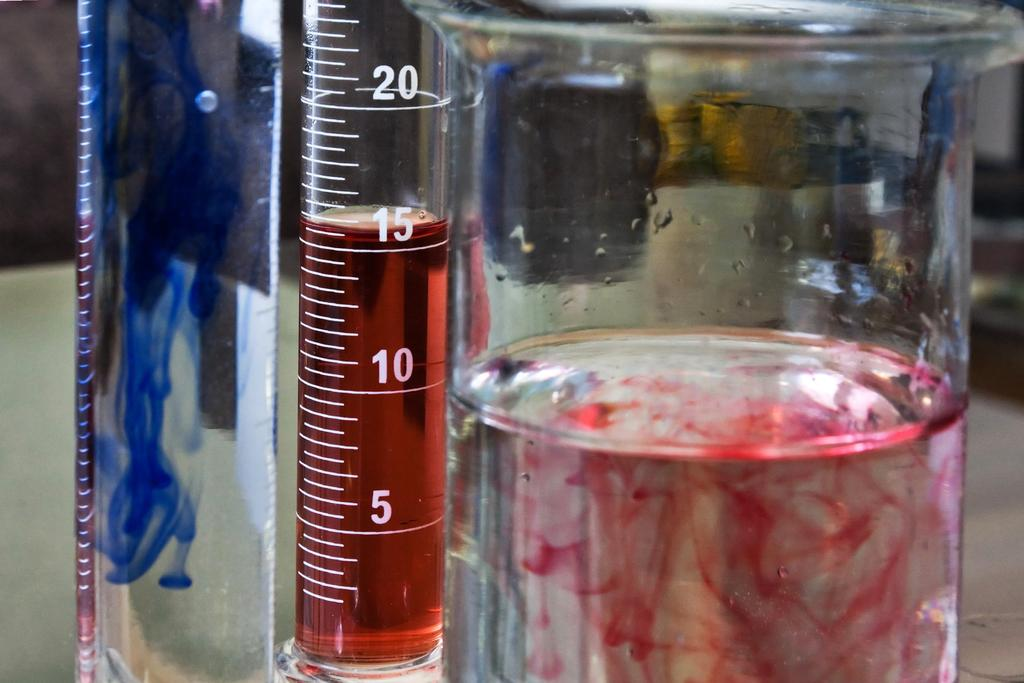Provide a one-sentence caption for the provided image. TWO TEST TUBES, ONE CONTAINS BLUE DYE AND THE OTHER RED, AND THE RED ONE IS AT 15ML. 